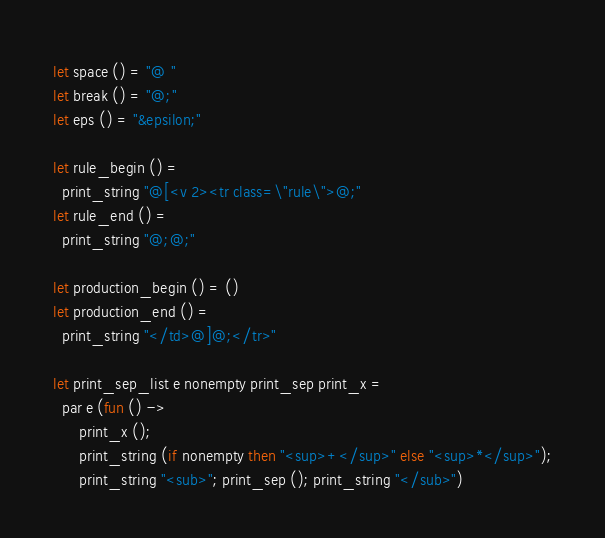<code> <loc_0><loc_0><loc_500><loc_500><_OCaml_>let space () = "@ "
let break () = "@;"
let eps () = "&epsilon;"

let rule_begin () =
  print_string "@[<v 2><tr class=\"rule\">@;"
let rule_end () =
  print_string "@;@;"

let production_begin () = ()
let production_end () =
  print_string "</td>@]@;</tr>"

let print_sep_list e nonempty print_sep print_x =
  par e (fun () ->
      print_x ();
      print_string (if nonempty then "<sup>+</sup>" else "<sup>*</sup>");
      print_string "<sub>"; print_sep (); print_string "</sub>")
</code> 